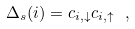Convert formula to latex. <formula><loc_0><loc_0><loc_500><loc_500>\Delta _ { s } ( i ) = c _ { i , \downarrow } c _ { i , \uparrow } \ ,</formula> 